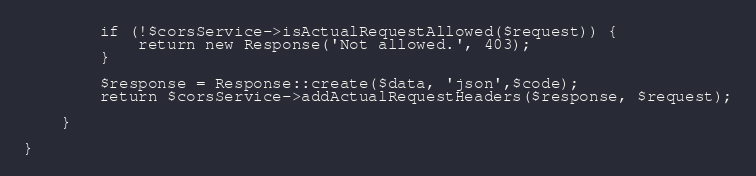<code> <loc_0><loc_0><loc_500><loc_500><_PHP_>        if (!$corsService->isActualRequestAllowed($request)) {
            return new Response('Not allowed.', 403);
        }

        $response = Response::create($data, 'json',$code);
        return $corsService->addActualRequestHeaders($response, $request);

    }

}
</code> 